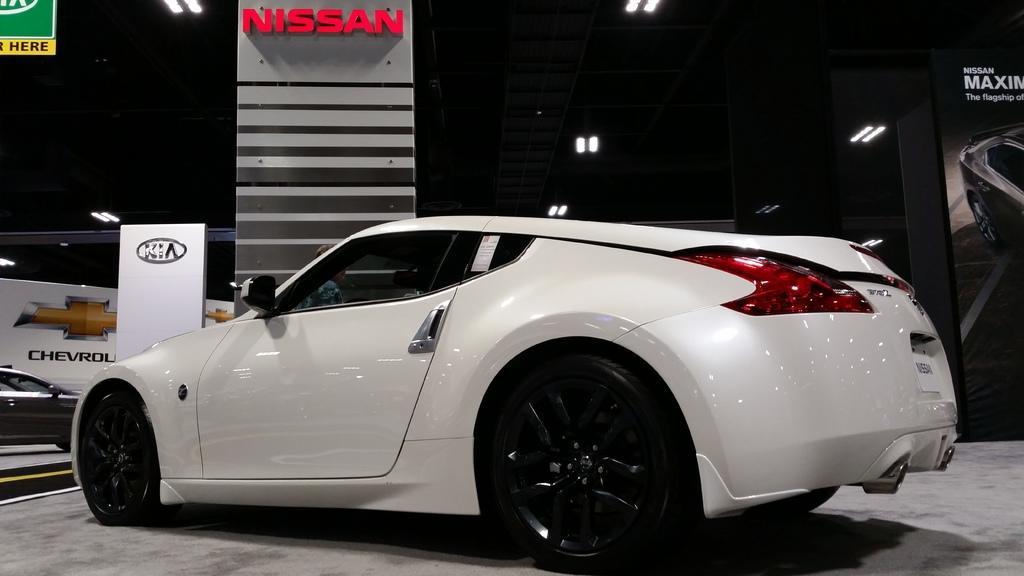How would you summarize this image in a sentence or two? In this picture there is a white color sports Nissan car parked in the showroom. Behind there is a naming board and white banner. In the background there is a black shed and white tube lights. 